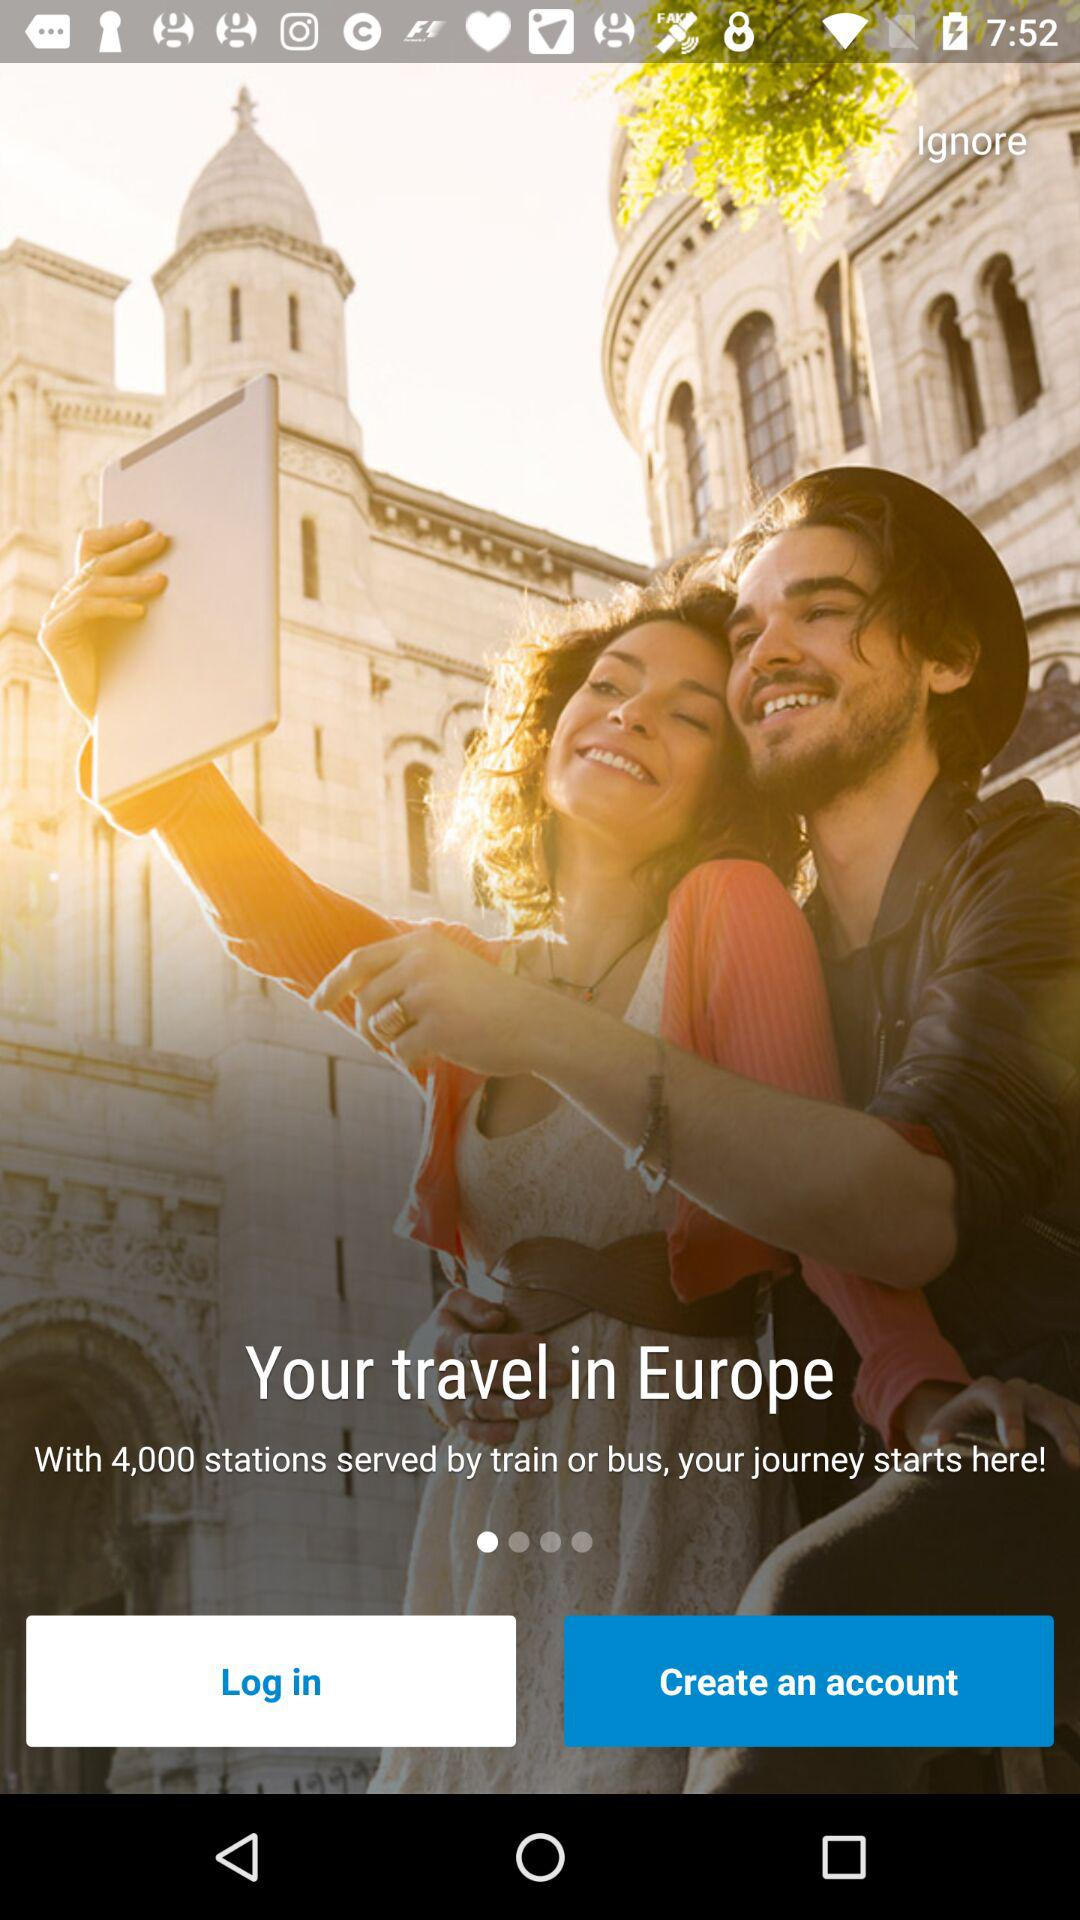How many stations are served by train or bus? There are 4,000 stations served by train or bus. 